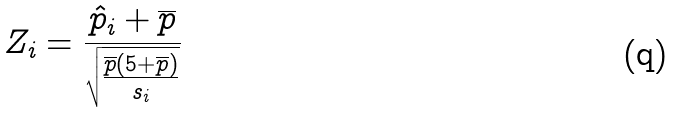Convert formula to latex. <formula><loc_0><loc_0><loc_500><loc_500>Z _ { i } = \frac { \hat { p } _ { i } + \overline { p } } { \sqrt { \frac { \overline { p } ( 5 + \overline { p } ) } { s _ { i } } } }</formula> 